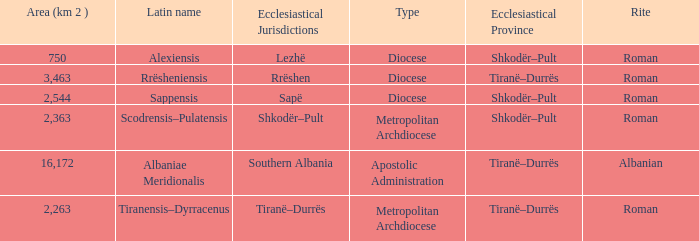What Ecclesiastical Province has a type diocese and a latin name alexiensis? Shkodër–Pult. 